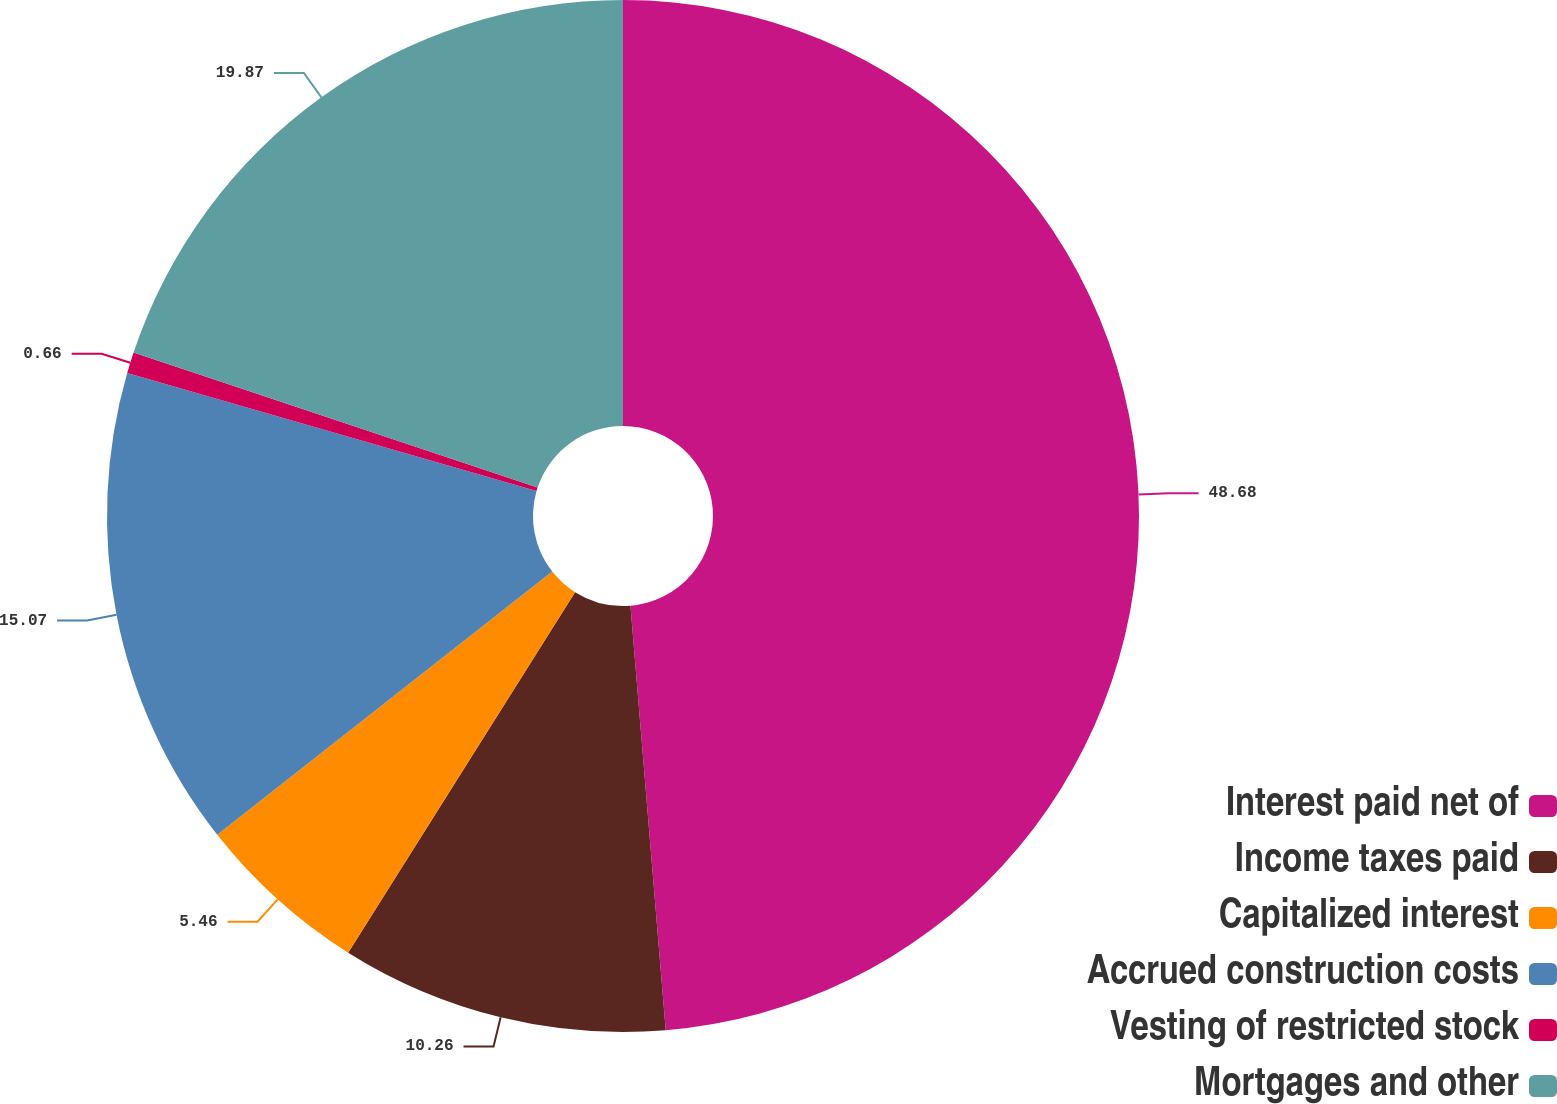Convert chart to OTSL. <chart><loc_0><loc_0><loc_500><loc_500><pie_chart><fcel>Interest paid net of<fcel>Income taxes paid<fcel>Capitalized interest<fcel>Accrued construction costs<fcel>Vesting of restricted stock<fcel>Mortgages and other<nl><fcel>48.68%<fcel>10.26%<fcel>5.46%<fcel>15.07%<fcel>0.66%<fcel>19.87%<nl></chart> 